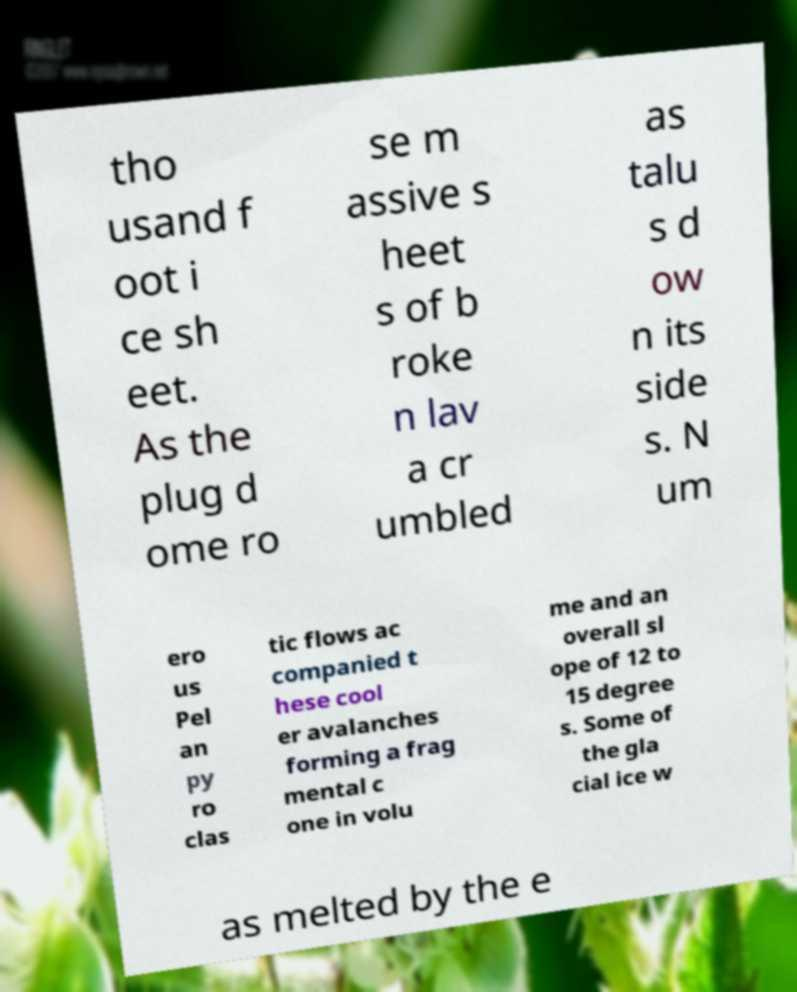Can you read and provide the text displayed in the image?This photo seems to have some interesting text. Can you extract and type it out for me? tho usand f oot i ce sh eet. As the plug d ome ro se m assive s heet s of b roke n lav a cr umbled as talu s d ow n its side s. N um ero us Pel an py ro clas tic flows ac companied t hese cool er avalanches forming a frag mental c one in volu me and an overall sl ope of 12 to 15 degree s. Some of the gla cial ice w as melted by the e 